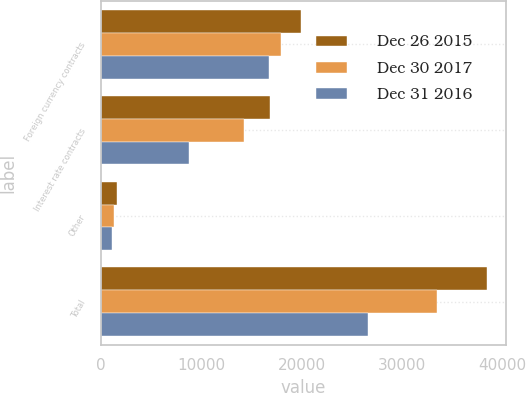<chart> <loc_0><loc_0><loc_500><loc_500><stacked_bar_chart><ecel><fcel>Foreign currency contracts<fcel>Interest rate contracts<fcel>Other<fcel>Total<nl><fcel>Dec 26 2015<fcel>19958<fcel>16823<fcel>1636<fcel>38417<nl><fcel>Dec 30 2017<fcel>17960<fcel>14228<fcel>1340<fcel>33528<nl><fcel>Dec 31 2016<fcel>16721<fcel>8812<fcel>1122<fcel>26655<nl></chart> 